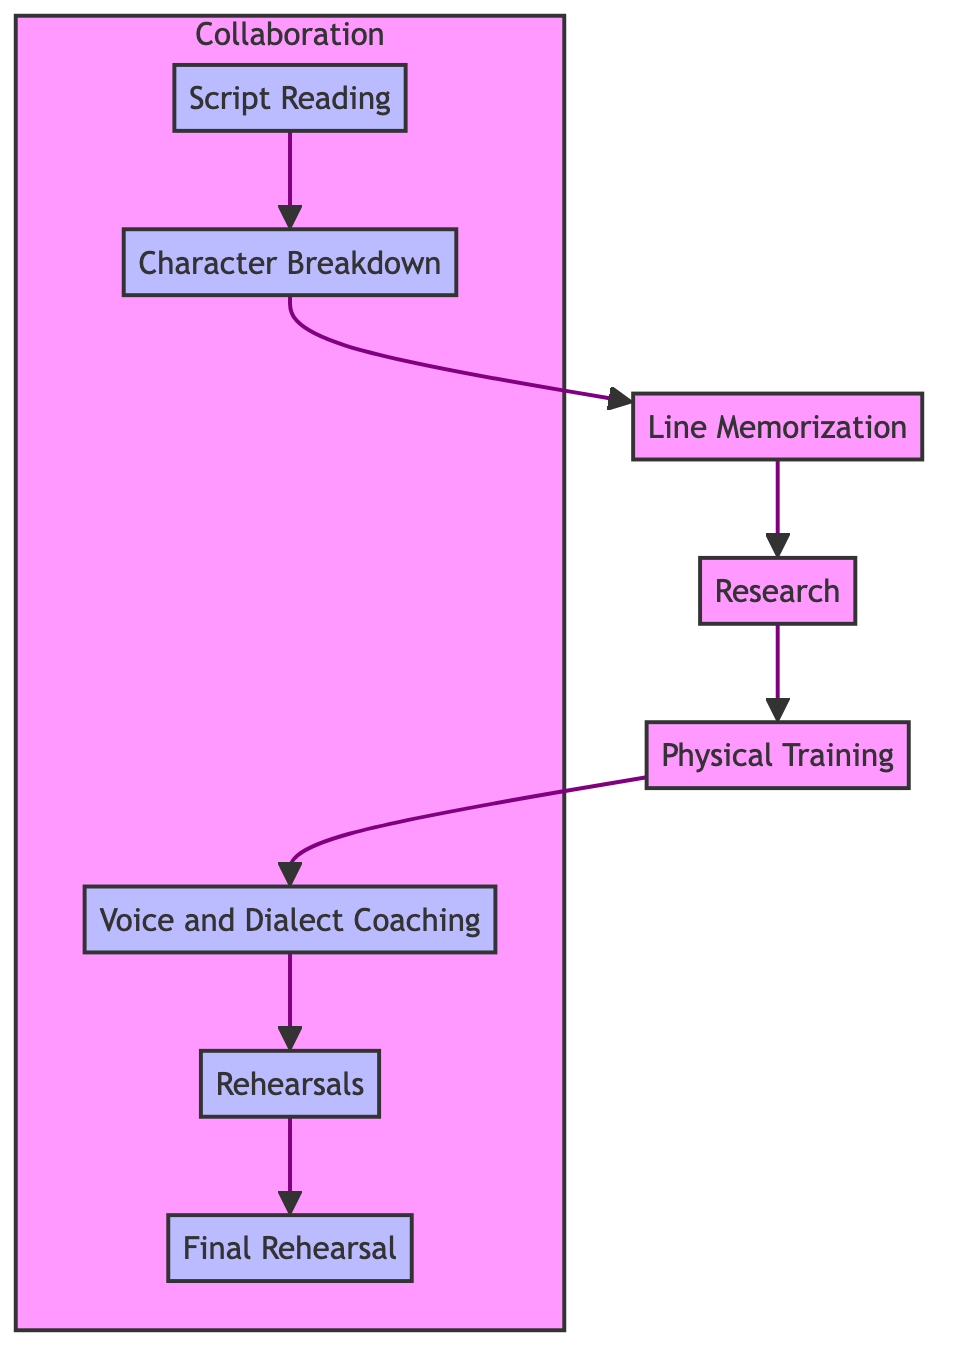What is the first step in the actor's preparation routine? The diagram indicates that the first step is "Script Reading."
Answer: Script Reading How many steps are there in total? By counting each of the nodes in the diagram from "Script Reading" to "Final Rehearsal," there are eight distinct steps.
Answer: 8 Which step involves working with a voice coach? The diagram specifies that "Voice and Dialect Coaching" is the step involving a voice coach.
Answer: Voice and Dialect Coaching What is the last step before the final rehearsal? The diagram shows that "Rehearsals" precedes the "Final Rehearsal."
Answer: Rehearsals Which two steps involve collaboration with the scriptwriter? "Script Reading" and "Character Breakdown" both involve collaboration with the scriptwriter, as indicated in the diagram.
Answer: Script Reading, Character Breakdown What is a necessary step for an actor to match the character's physical traits? The diagram indicates that "Physical Training" is necessary for the actor to match the character's physical traits.
Answer: Physical Training Which step comes after "Line Memorization"? According to the flow of the diagram, "Research" follows "Line Memorization."
Answer: Research How many steps involve collaboration with the sound engineer? The diagram clearly identifies two steps: "Voice and Dialect Coaching" and "Rehearsals" involve collaboration with the sound engineer.
Answer: 2 What is the relationship between "Final Rehearsal" and "Rehearsals"? The diagram shows that "Final Rehearsal" is the direct successor of "Rehearsals," indicating that it occurs after.
Answer: Final Rehearsal is after Rehearsals 